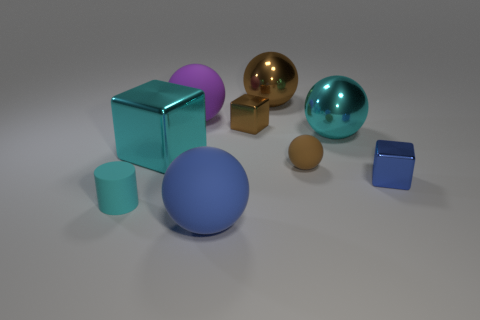If we were to categorize the objects by shape, what groups would we have? The objects can be categorized into three groups based on their shapes. The first group would include the spheres, encompassing the cyan, golden-yellow, and small brown ball. The second group consists of the cubes, with one large teal cube and a smaller navy blue one. Finally, the third grouping would have the cylinders, with one tall teal cylinder and the metallic looking shorter one. 